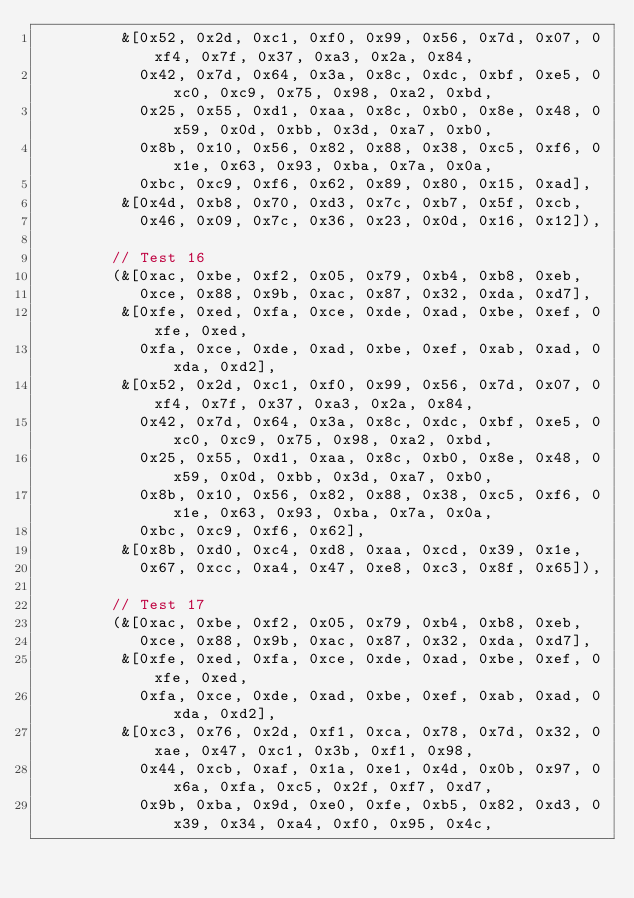<code> <loc_0><loc_0><loc_500><loc_500><_Rust_>         &[0x52, 0x2d, 0xc1, 0xf0, 0x99, 0x56, 0x7d, 0x07, 0xf4, 0x7f, 0x37, 0xa3, 0x2a, 0x84,
           0x42, 0x7d, 0x64, 0x3a, 0x8c, 0xdc, 0xbf, 0xe5, 0xc0, 0xc9, 0x75, 0x98, 0xa2, 0xbd,
           0x25, 0x55, 0xd1, 0xaa, 0x8c, 0xb0, 0x8e, 0x48, 0x59, 0x0d, 0xbb, 0x3d, 0xa7, 0xb0,
           0x8b, 0x10, 0x56, 0x82, 0x88, 0x38, 0xc5, 0xf6, 0x1e, 0x63, 0x93, 0xba, 0x7a, 0x0a,
           0xbc, 0xc9, 0xf6, 0x62, 0x89, 0x80, 0x15, 0xad],
         &[0x4d, 0xb8, 0x70, 0xd3, 0x7c, 0xb7, 0x5f, 0xcb,
           0x46, 0x09, 0x7c, 0x36, 0x23, 0x0d, 0x16, 0x12]),

        // Test 16
        (&[0xac, 0xbe, 0xf2, 0x05, 0x79, 0xb4, 0xb8, 0xeb,
           0xce, 0x88, 0x9b, 0xac, 0x87, 0x32, 0xda, 0xd7],
         &[0xfe, 0xed, 0xfa, 0xce, 0xde, 0xad, 0xbe, 0xef, 0xfe, 0xed,
           0xfa, 0xce, 0xde, 0xad, 0xbe, 0xef, 0xab, 0xad, 0xda, 0xd2],
         &[0x52, 0x2d, 0xc1, 0xf0, 0x99, 0x56, 0x7d, 0x07, 0xf4, 0x7f, 0x37, 0xa3, 0x2a, 0x84,
           0x42, 0x7d, 0x64, 0x3a, 0x8c, 0xdc, 0xbf, 0xe5, 0xc0, 0xc9, 0x75, 0x98, 0xa2, 0xbd,
           0x25, 0x55, 0xd1, 0xaa, 0x8c, 0xb0, 0x8e, 0x48, 0x59, 0x0d, 0xbb, 0x3d, 0xa7, 0xb0,
           0x8b, 0x10, 0x56, 0x82, 0x88, 0x38, 0xc5, 0xf6, 0x1e, 0x63, 0x93, 0xba, 0x7a, 0x0a,
           0xbc, 0xc9, 0xf6, 0x62],
         &[0x8b, 0xd0, 0xc4, 0xd8, 0xaa, 0xcd, 0x39, 0x1e,
           0x67, 0xcc, 0xa4, 0x47, 0xe8, 0xc3, 0x8f, 0x65]),

        // Test 17
        (&[0xac, 0xbe, 0xf2, 0x05, 0x79, 0xb4, 0xb8, 0xeb,
           0xce, 0x88, 0x9b, 0xac, 0x87, 0x32, 0xda, 0xd7],
         &[0xfe, 0xed, 0xfa, 0xce, 0xde, 0xad, 0xbe, 0xef, 0xfe, 0xed,
           0xfa, 0xce, 0xde, 0xad, 0xbe, 0xef, 0xab, 0xad, 0xda, 0xd2],
         &[0xc3, 0x76, 0x2d, 0xf1, 0xca, 0x78, 0x7d, 0x32, 0xae, 0x47, 0xc1, 0x3b, 0xf1, 0x98,
           0x44, 0xcb, 0xaf, 0x1a, 0xe1, 0x4d, 0x0b, 0x97, 0x6a, 0xfa, 0xc5, 0x2f, 0xf7, 0xd7,
           0x9b, 0xba, 0x9d, 0xe0, 0xfe, 0xb5, 0x82, 0xd3, 0x39, 0x34, 0xa4, 0xf0, 0x95, 0x4c,</code> 